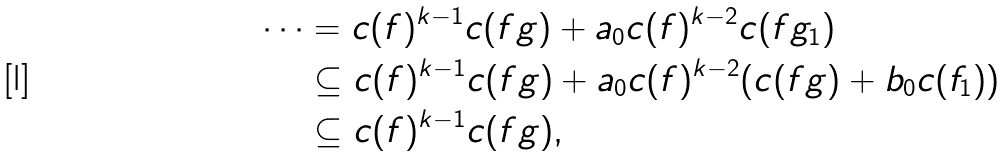<formula> <loc_0><loc_0><loc_500><loc_500>\cdots & = c ( f ) ^ { k - 1 } c ( f g ) + a _ { 0 } c ( f ) ^ { k - 2 } c ( f g _ { 1 } ) \\ & \subseteq c ( f ) ^ { k - 1 } c ( f g ) + a _ { 0 } c ( f ) ^ { k - 2 } ( c ( f g ) + b _ { 0 } c ( f _ { 1 } ) ) \\ & \subseteq c ( f ) ^ { k - 1 } c ( f g ) ,</formula> 